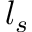Convert formula to latex. <formula><loc_0><loc_0><loc_500><loc_500>l _ { s }</formula> 